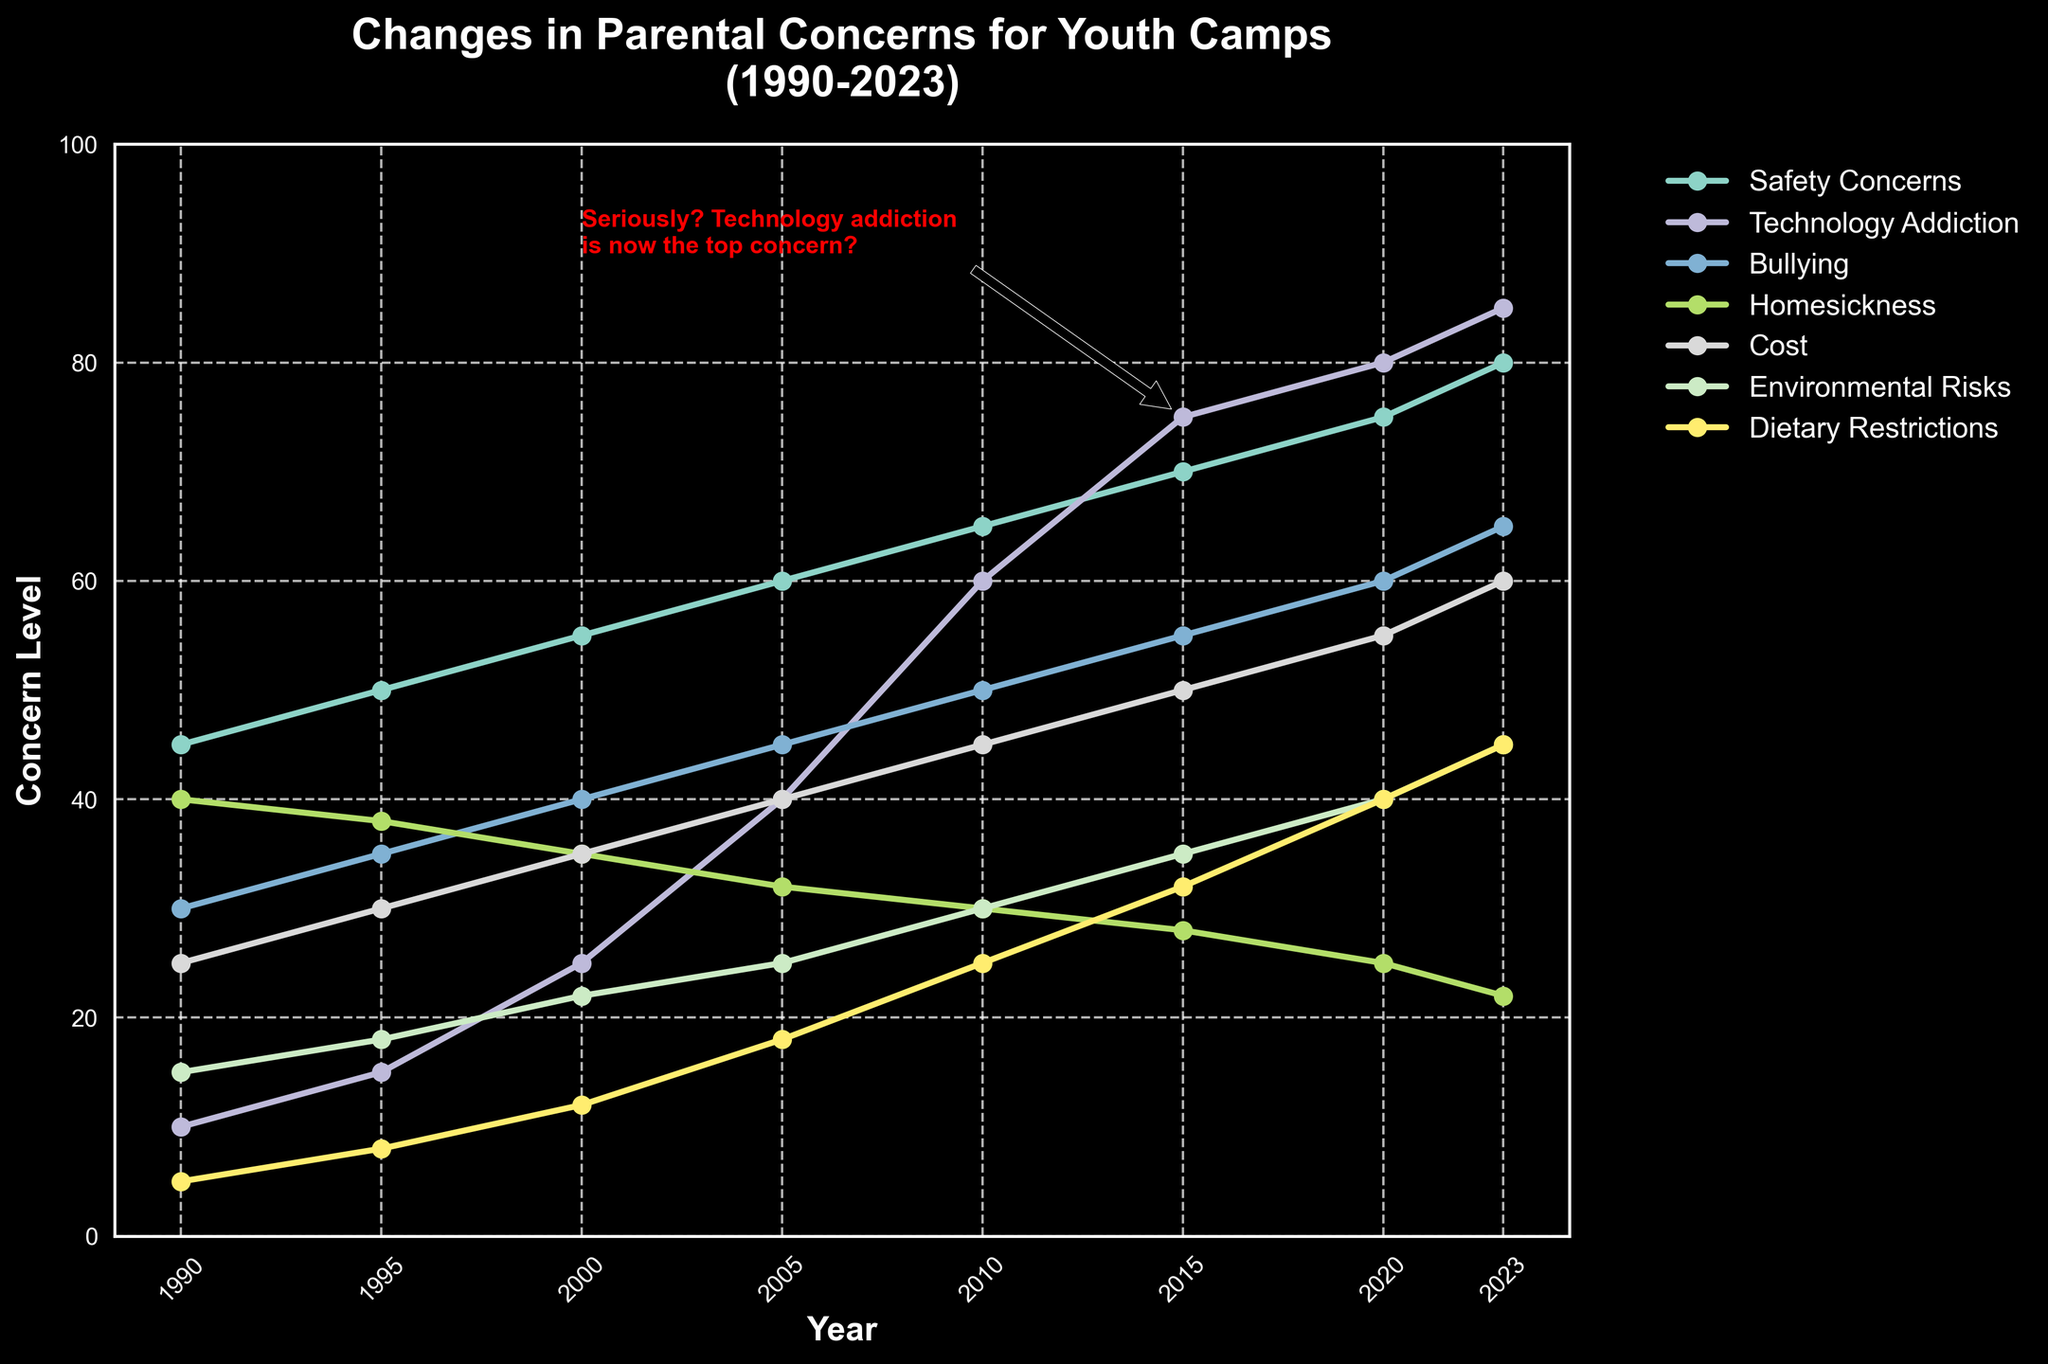What concern had the steepest increase from 1990 to 2023? To find the steepest increase, compare the differences between the 2023 and 1990 values for each concern. Technology Addiction increased from 10 to 85, which is a difference of 75, the largest increase among the concerns.
Answer: Technology Addiction By how many points did concerns about Environmental Risks increase from 1990 to 2023? Environmental Risks in 1990 was 15 and in 2023 it's 45. The increase is 45 - 15 = 30 points.
Answer: 30 Which concerns were equal in 2005, and what were their values? Look at the 2005 value for each concern. Both Homesickness and Cost were equal at 32.
Answer: Homesickness and Cost, 32 Which concern had the smallest increase from 1990 to 2023? Calculate the differences between the values in 2023 and 1990 for each concern. Homesickness increased from 40 to 22, which is a decrease, meaning it had the smallest increase.
Answer: Homesickness What was the highest level of Safety Concerns and in which year did it occur? Scan the Safety Concerns data line to see its peak and identify the corresponding year. Safety Concerns peaked at 80 in 2023.
Answer: 80, 2023 In which year did Technology Addiction surpass Safety Concerns? Track both lines visually to see when the Technology Addiction line goes above the Safety Concerns line. This happened in 2015.
Answer: 2015 What is the difference in concern levels for Cost between 1990 and 2010, and how about between 2010 and 2023? For the first period: 1990 (25) to 2010 (45), the difference is 45 - 25 = 20. For the second period: 2010 (45) to 2023 (60), the difference is 60 - 45 = 15.
Answer: 20, 15 What trends can you identify about Homesickness concerns over the years? Homesickness concerns steadily decreased from 40 in 1990 to 22 in 2023. It shows a clear downward trend over the years, with slight variations.
Answer: Steady decrease Which concerns crossed the 50-point mark first? Cross-check each concern line to find which one reached above 50 first; Bullying crossed 50 by the year 2000.
Answer: Bullying By how many points did Safety Concerns increase between 1995 and 2000? In 1995, Safety Concerns were at 50 and by 2000, they were at 55. The increase is 55 - 50 = 5 points.
Answer: 5 